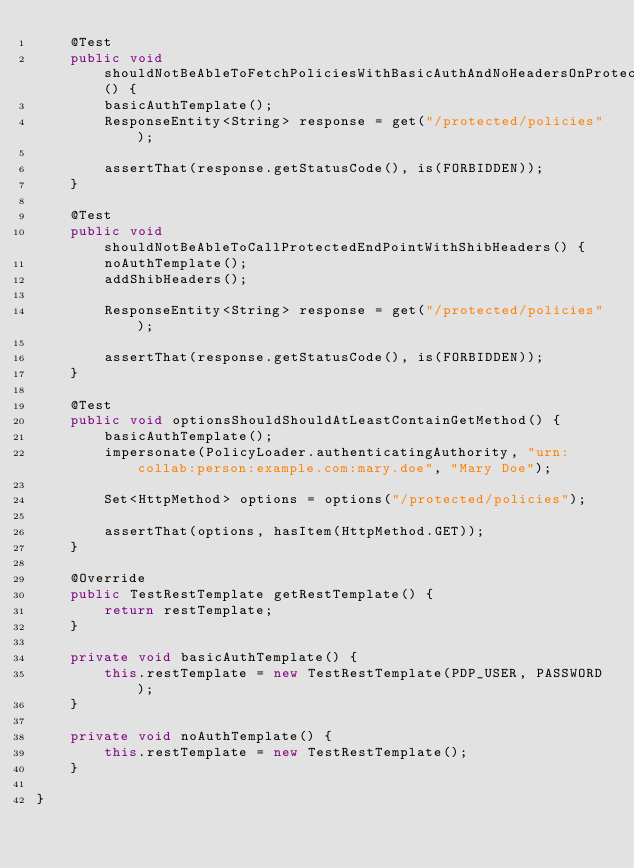Convert code to text. <code><loc_0><loc_0><loc_500><loc_500><_Java_>    @Test
    public void shouldNotBeAbleToFetchPoliciesWithBasicAuthAndNoHeadersOnProtectedEndPoint() {
        basicAuthTemplate();
        ResponseEntity<String> response = get("/protected/policies");

        assertThat(response.getStatusCode(), is(FORBIDDEN));
    }

    @Test
    public void shouldNotBeAbleToCallProtectedEndPointWithShibHeaders() {
        noAuthTemplate();
        addShibHeaders();

        ResponseEntity<String> response = get("/protected/policies");

        assertThat(response.getStatusCode(), is(FORBIDDEN));
    }

    @Test
    public void optionsShouldShouldAtLeastContainGetMethod() {
        basicAuthTemplate();
        impersonate(PolicyLoader.authenticatingAuthority, "urn:collab:person:example.com:mary.doe", "Mary Doe");

        Set<HttpMethod> options = options("/protected/policies");

        assertThat(options, hasItem(HttpMethod.GET));
    }

    @Override
    public TestRestTemplate getRestTemplate() {
        return restTemplate;
    }

    private void basicAuthTemplate() {
        this.restTemplate = new TestRestTemplate(PDP_USER, PASSWORD);
    }

    private void noAuthTemplate() {
        this.restTemplate = new TestRestTemplate();
    }

}</code> 